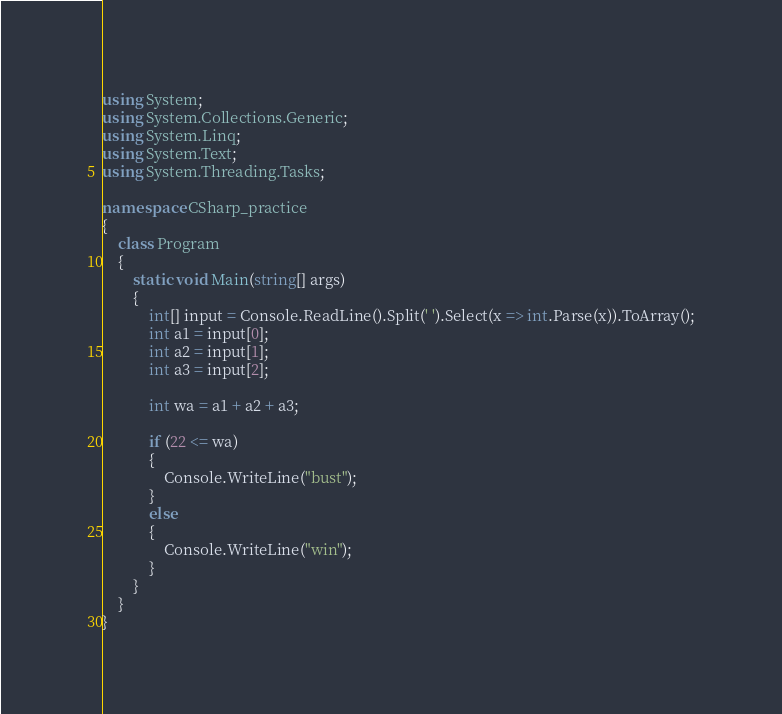<code> <loc_0><loc_0><loc_500><loc_500><_C#_>using System;
using System.Collections.Generic;
using System.Linq;
using System.Text;
using System.Threading.Tasks;

namespace CSharp_practice
{
    class Program
    {
        static void Main(string[] args)
        {
            int[] input = Console.ReadLine().Split(' ').Select(x => int.Parse(x)).ToArray();
            int a1 = input[0];
            int a2 = input[1];
            int a3 = input[2];

            int wa = a1 + a2 + a3;

            if (22 <= wa)
            {
                Console.WriteLine("bust");
            }
            else
            {
                Console.WriteLine("win");
            }
        }
    }
}
</code> 